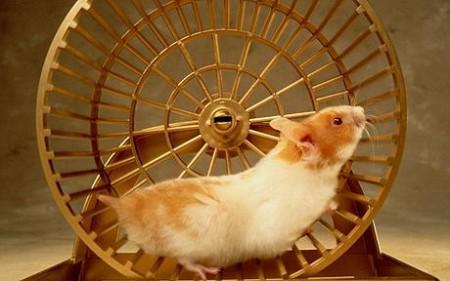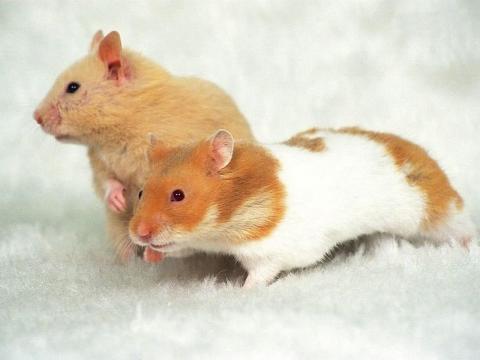The first image is the image on the left, the second image is the image on the right. Assess this claim about the two images: "One of the hamsters is in a metal wheel.". Correct or not? Answer yes or no. Yes. 